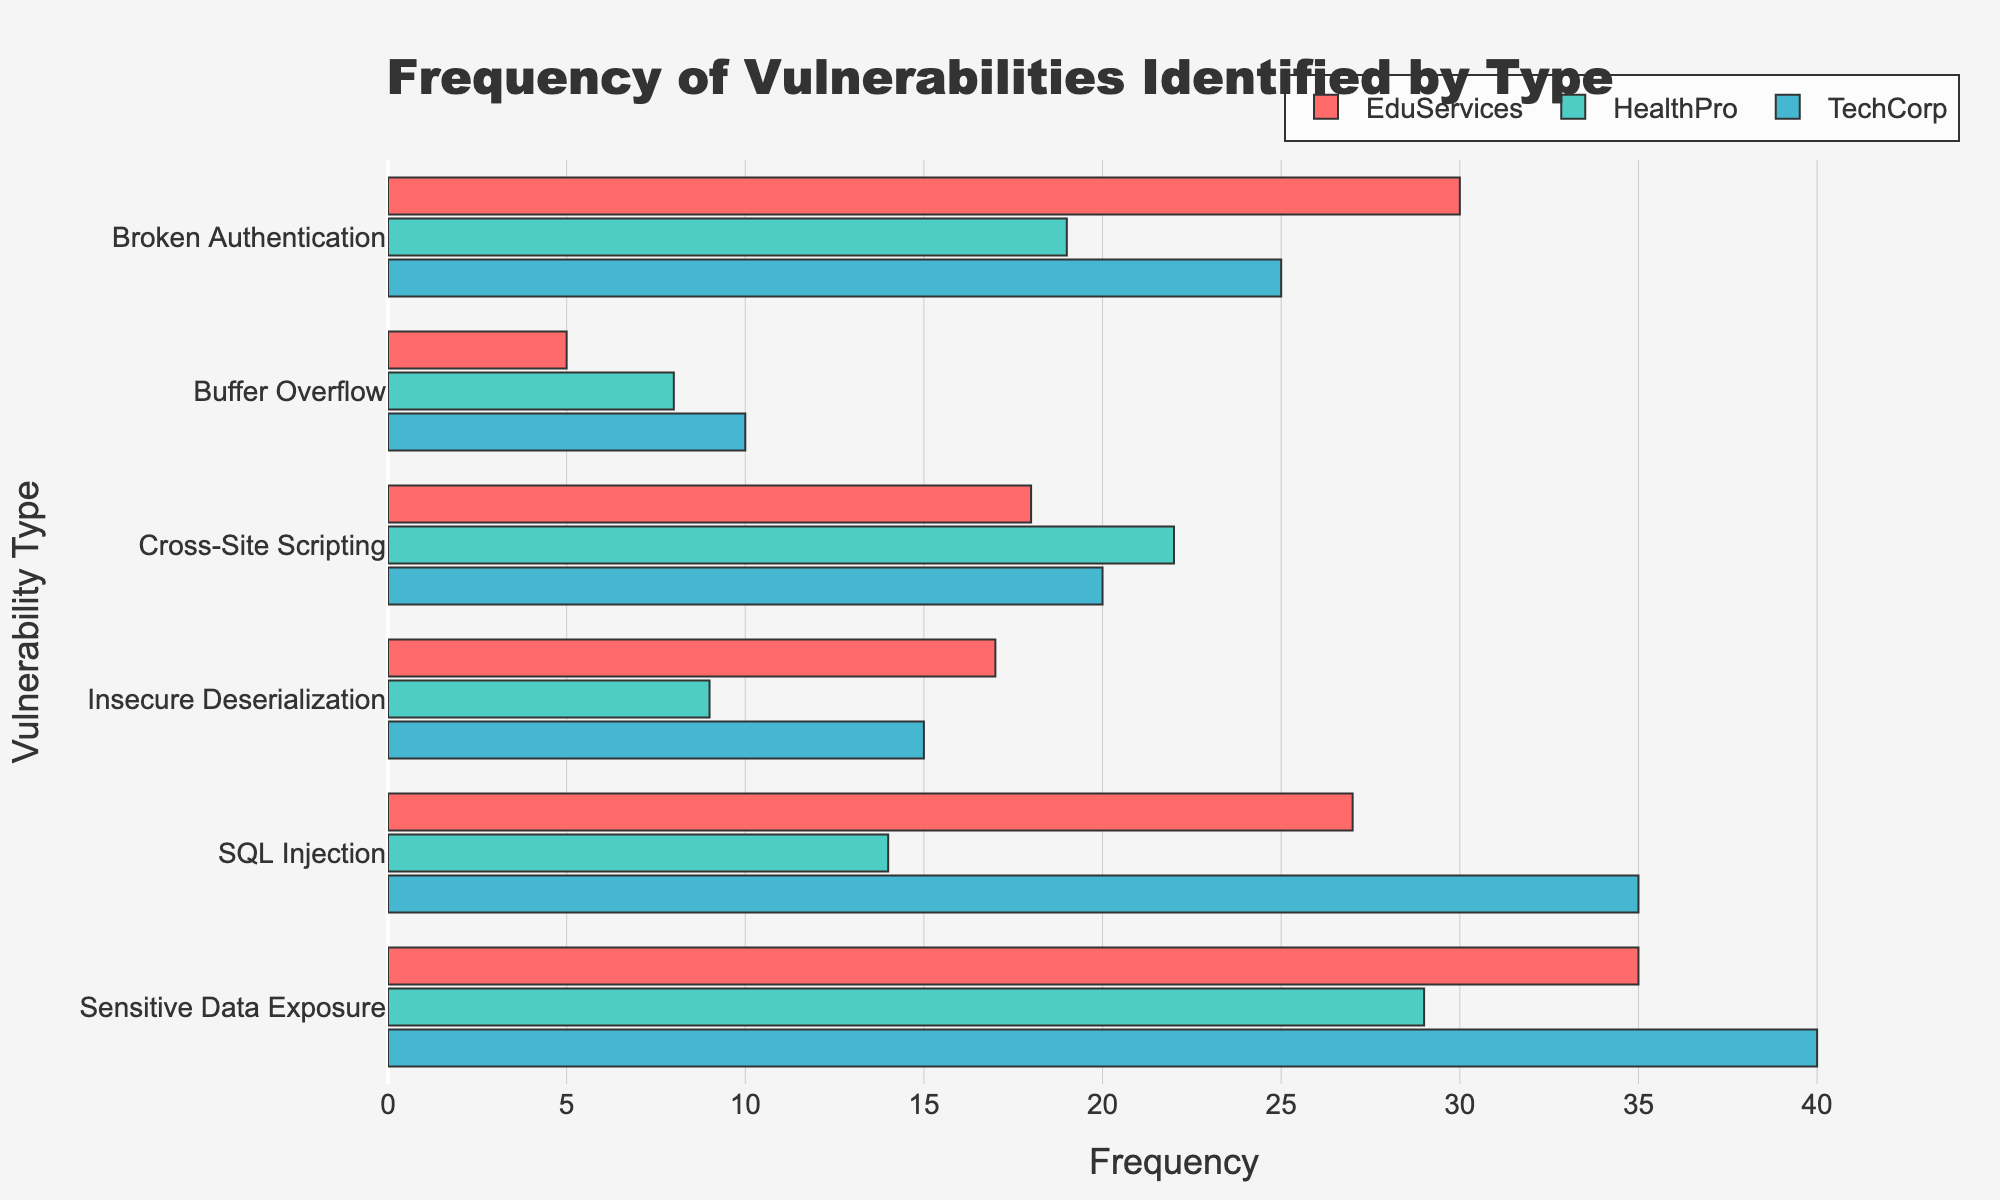What's the most frequent vulnerability identified for TechCorp? By observing the longest bar for TechCorp, the "Sensitive Data Exposure" bar is the longest, indicating its highest frequency.
Answer: Sensitive Data Exposure Which company has the highest frequency of SQL Injection vulnerabilities? By comparing the lengths of the bars related to SQL Injection for each company, TechCorp has the longest bar, representing the highest frequency.
Answer: TechCorp How does the frequency of Broken Authentication vulnerabilities for HealthPro compare to TechCorp? Comparing the bars for Broken Authentication, TechCorp has a bar with a frequency of 25 while HealthPro has a bar with a frequency of 19, indicating TechCorp has more vulnerabilities in this category.
Answer: TechCorp > HealthPro What is the sum of frequencies for Buffer Overflow vulnerabilities across all three companies? Adding the frequencies of Buffer Overflow vulnerabilities: 10 (TechCorp) + 5 (EduServices) + 8 (HealthPro), the total is 23.
Answer: 23 Which company has the lowest frequency of Insecure Deserialization vulnerabilities? Comparing the bars for Insecure Deserialization, HealthPro has the shortest bar, indicating the lowest frequency.
Answer: HealthPro Are the frequencies of Cross-Site Scripting vulnerabilities higher or lower for EduServices compared to TechCorp? Comparing the lengths of the bars for Cross-Site Scripting, TechCorp has a bar with a frequency of 20 while EduServices has a bar with a frequency of 18, indicating EduServices has a lower frequency.
Answer: Lower Calculate the average frequency of SQL Injection vulnerabilities across the three companies. Summing the frequencies of SQL Injection vulnerabilities: 35 (TechCorp) + 27 (EduServices) + 14 (HealthPro) gives a total of 76. Dividing by 3, the average is approximately 25.33.
Answer: 25.33 Between Broken Authentication and Sensitive Data Exposure, which vulnerability type has a higher total frequency for all companies combined? Summing the frequencies for each vulnerability type: Broken Authentication (25+30+19=74) and Sensitive Data Exposure (40+35+29=104). Sensitive Data Exposure has a higher total frequency.
Answer: Sensitive Data Exposure What is the difference in the frequency of Insecure Deserialization vulnerabilities between EduServices and HealthPro? Subtracting the frequency for HealthPro from EduServices: 17 - 9 equals 8.
Answer: 8 